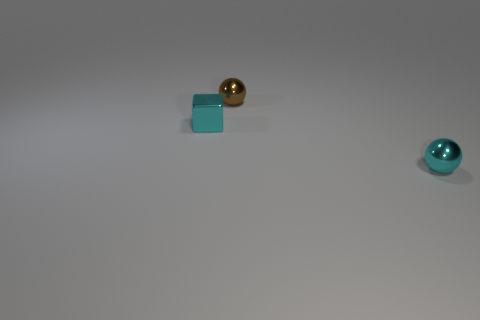Add 1 cyan cubes. How many objects exist? 4 Subtract all blocks. How many objects are left? 2 Subtract 0 red cylinders. How many objects are left? 3 Subtract all shiny cubes. Subtract all brown objects. How many objects are left? 1 Add 2 metallic blocks. How many metallic blocks are left? 3 Add 1 small brown things. How many small brown things exist? 2 